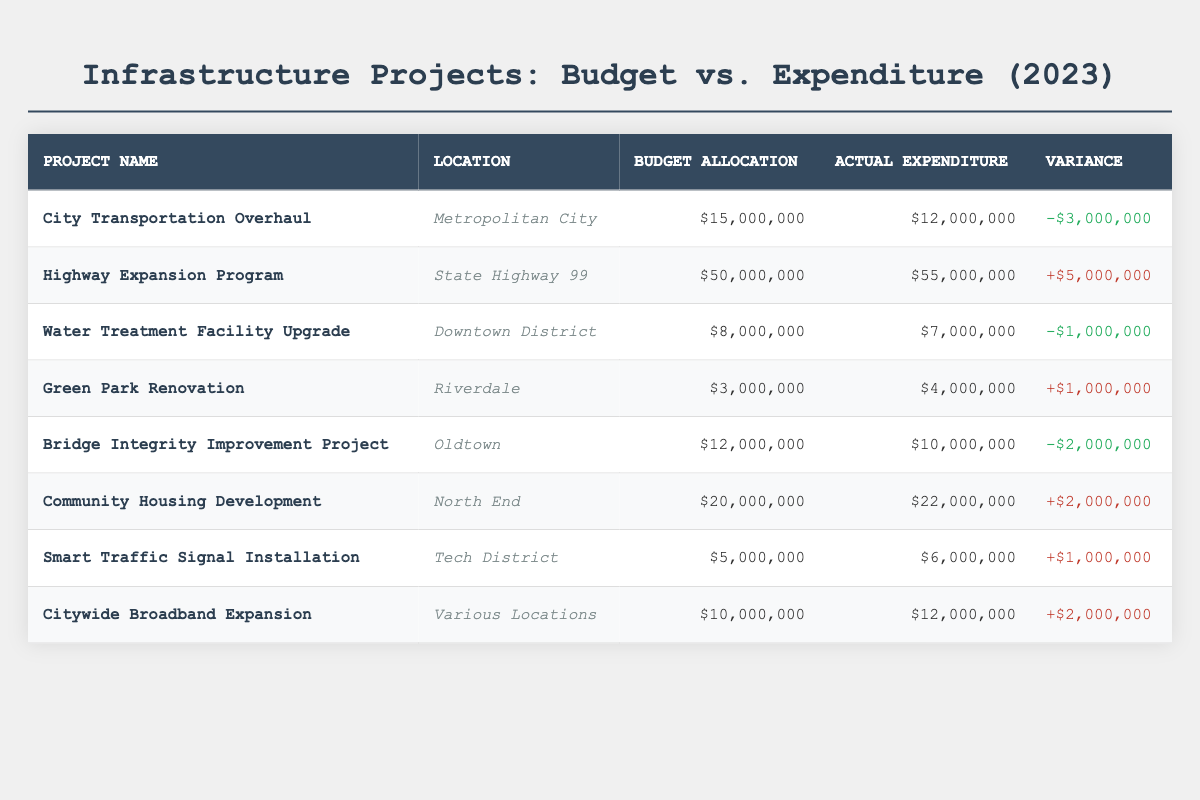What is the actual expenditure for the "City Transportation Overhaul" project? The table lists the actual expenditure for the "City Transportation Overhaul" project in the "Actual Expenditure" column, which shows $12,000,000.
Answer: $12,000,000 How much is the variance for the "Community Housing Development" project? The variance is calculated by subtracting the budget allocation from the actual expenditure for "Community Housing Development," which is $22,000,000 - $20,000,000 = +$2,000,000.
Answer: +$2,000,000 Which project had the highest actual expenditure in 2023? By reviewing the "Actual Expenditure" column, the "Highway Expansion Program" has the highest actual expenditure of $55,000,000.
Answer: Highway Expansion Program Are there any projects that spent less than their budget allocation? Yes, the "City Transportation Overhaul," "Water Treatment Facility Upgrade," and "Bridge Integrity Improvement Project" each spent less than their budget allocation.
Answer: Yes What is the total budget allocation across all projects listed in the table? Summing the budget allocations: $15,000,000 + $50,000,000 + $8,000,000 + $3,000,000 + $12,000,000 + $20,000,000 + $5,000,000 + $10,000,000 = $123,000,000.
Answer: $123,000,000 How many projects went over budget in 2023? There are four projects listed as over-budget: "Highway Expansion Program," "Green Park Renovation," "Community Housing Development," and "Smart Traffic Signal Installation," making a total of four projects.
Answer: 4 What is the average actual expenditure of all infrastructure projects in 2023? To find the average, we first sum all actual expenditures: $12,000,000 + $55,000,000 + $7,000,000 + $4,000,000 + $10,000,000 + $22,000,000 + $6,000,000 + $12,000,000 = $114,000,000. Then, divide by the number of projects (8): $114,000,000 / 8 = $14,250,000.
Answer: $14,250,000 Which project had the most significant budget overrun? The "Highway Expansion Program" has the largest overrun of $5,000,000, calculated as actual expenditure of $55,000,000 minus budget allocation of $50,000,000.
Answer: Highway Expansion Program What is the ratio of budget allocation to actual expenditure for the "Smart Traffic Signal Installation" project? To find the ratio, divide the budget allocation $5,000,000 by the actual expenditure $6,000,000, resulting in a ratio of 5:6.
Answer: 5:6 Is it true that all projects had their actual expenditure equal to or less than budget allocation? No, it is false because several projects, including the "Highway Expansion Program" and "Community Housing Development," exceeded their budget allocation.
Answer: No 